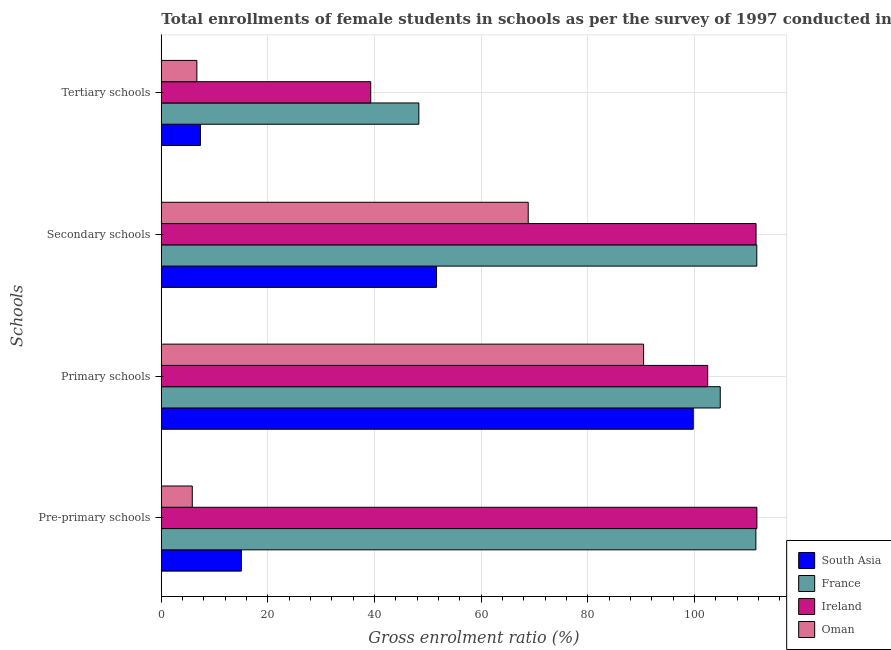How many groups of bars are there?
Make the answer very short. 4. Are the number of bars per tick equal to the number of legend labels?
Ensure brevity in your answer.  Yes. How many bars are there on the 4th tick from the top?
Offer a terse response. 4. What is the label of the 3rd group of bars from the top?
Offer a terse response. Primary schools. What is the gross enrolment ratio(female) in primary schools in Ireland?
Your answer should be compact. 102.49. Across all countries, what is the maximum gross enrolment ratio(female) in pre-primary schools?
Make the answer very short. 111.72. Across all countries, what is the minimum gross enrolment ratio(female) in secondary schools?
Provide a short and direct response. 51.63. In which country was the gross enrolment ratio(female) in pre-primary schools maximum?
Ensure brevity in your answer.  Ireland. In which country was the gross enrolment ratio(female) in primary schools minimum?
Your response must be concise. Oman. What is the total gross enrolment ratio(female) in secondary schools in the graph?
Your answer should be compact. 343.73. What is the difference between the gross enrolment ratio(female) in primary schools in South Asia and that in Oman?
Provide a succinct answer. 9.31. What is the difference between the gross enrolment ratio(female) in secondary schools in South Asia and the gross enrolment ratio(female) in tertiary schools in Ireland?
Your answer should be compact. 12.35. What is the average gross enrolment ratio(female) in tertiary schools per country?
Provide a succinct answer. 25.4. What is the difference between the gross enrolment ratio(female) in tertiary schools and gross enrolment ratio(female) in secondary schools in Oman?
Provide a short and direct response. -62.16. What is the ratio of the gross enrolment ratio(female) in primary schools in Oman to that in France?
Make the answer very short. 0.86. What is the difference between the highest and the second highest gross enrolment ratio(female) in pre-primary schools?
Your answer should be compact. 0.19. What is the difference between the highest and the lowest gross enrolment ratio(female) in pre-primary schools?
Your response must be concise. 105.91. In how many countries, is the gross enrolment ratio(female) in tertiary schools greater than the average gross enrolment ratio(female) in tertiary schools taken over all countries?
Your answer should be compact. 2. Is it the case that in every country, the sum of the gross enrolment ratio(female) in pre-primary schools and gross enrolment ratio(female) in primary schools is greater than the sum of gross enrolment ratio(female) in tertiary schools and gross enrolment ratio(female) in secondary schools?
Provide a short and direct response. Yes. What does the 1st bar from the top in Tertiary schools represents?
Offer a terse response. Oman. What does the 4th bar from the bottom in Tertiary schools represents?
Provide a succinct answer. Oman. How many bars are there?
Give a very brief answer. 16. How many countries are there in the graph?
Provide a succinct answer. 4. Does the graph contain grids?
Provide a succinct answer. Yes. How many legend labels are there?
Make the answer very short. 4. What is the title of the graph?
Offer a terse response. Total enrollments of female students in schools as per the survey of 1997 conducted in different countries. What is the label or title of the X-axis?
Your answer should be very brief. Gross enrolment ratio (%). What is the label or title of the Y-axis?
Provide a short and direct response. Schools. What is the Gross enrolment ratio (%) of South Asia in Pre-primary schools?
Your answer should be very brief. 15.01. What is the Gross enrolment ratio (%) in France in Pre-primary schools?
Your response must be concise. 111.53. What is the Gross enrolment ratio (%) of Ireland in Pre-primary schools?
Provide a short and direct response. 111.72. What is the Gross enrolment ratio (%) of Oman in Pre-primary schools?
Give a very brief answer. 5.81. What is the Gross enrolment ratio (%) in South Asia in Primary schools?
Keep it short and to the point. 99.79. What is the Gross enrolment ratio (%) of France in Primary schools?
Your response must be concise. 104.85. What is the Gross enrolment ratio (%) in Ireland in Primary schools?
Provide a short and direct response. 102.49. What is the Gross enrolment ratio (%) in Oman in Primary schools?
Provide a succinct answer. 90.47. What is the Gross enrolment ratio (%) in South Asia in Secondary schools?
Your answer should be compact. 51.63. What is the Gross enrolment ratio (%) of France in Secondary schools?
Keep it short and to the point. 111.7. What is the Gross enrolment ratio (%) in Ireland in Secondary schools?
Ensure brevity in your answer.  111.57. What is the Gross enrolment ratio (%) of Oman in Secondary schools?
Make the answer very short. 68.83. What is the Gross enrolment ratio (%) in South Asia in Tertiary schools?
Your answer should be compact. 7.34. What is the Gross enrolment ratio (%) of France in Tertiary schools?
Give a very brief answer. 48.31. What is the Gross enrolment ratio (%) in Ireland in Tertiary schools?
Make the answer very short. 39.28. What is the Gross enrolment ratio (%) in Oman in Tertiary schools?
Your answer should be compact. 6.67. Across all Schools, what is the maximum Gross enrolment ratio (%) in South Asia?
Your answer should be very brief. 99.79. Across all Schools, what is the maximum Gross enrolment ratio (%) in France?
Your answer should be very brief. 111.7. Across all Schools, what is the maximum Gross enrolment ratio (%) in Ireland?
Ensure brevity in your answer.  111.72. Across all Schools, what is the maximum Gross enrolment ratio (%) of Oman?
Your answer should be compact. 90.47. Across all Schools, what is the minimum Gross enrolment ratio (%) of South Asia?
Ensure brevity in your answer.  7.34. Across all Schools, what is the minimum Gross enrolment ratio (%) of France?
Provide a succinct answer. 48.31. Across all Schools, what is the minimum Gross enrolment ratio (%) in Ireland?
Offer a very short reply. 39.28. Across all Schools, what is the minimum Gross enrolment ratio (%) in Oman?
Provide a succinct answer. 5.81. What is the total Gross enrolment ratio (%) in South Asia in the graph?
Keep it short and to the point. 173.77. What is the total Gross enrolment ratio (%) of France in the graph?
Your response must be concise. 376.4. What is the total Gross enrolment ratio (%) in Ireland in the graph?
Your answer should be very brief. 365.07. What is the total Gross enrolment ratio (%) in Oman in the graph?
Make the answer very short. 171.78. What is the difference between the Gross enrolment ratio (%) in South Asia in Pre-primary schools and that in Primary schools?
Make the answer very short. -84.77. What is the difference between the Gross enrolment ratio (%) in France in Pre-primary schools and that in Primary schools?
Ensure brevity in your answer.  6.68. What is the difference between the Gross enrolment ratio (%) of Ireland in Pre-primary schools and that in Primary schools?
Keep it short and to the point. 9.23. What is the difference between the Gross enrolment ratio (%) of Oman in Pre-primary schools and that in Primary schools?
Make the answer very short. -84.66. What is the difference between the Gross enrolment ratio (%) in South Asia in Pre-primary schools and that in Secondary schools?
Keep it short and to the point. -36.62. What is the difference between the Gross enrolment ratio (%) of France in Pre-primary schools and that in Secondary schools?
Ensure brevity in your answer.  -0.17. What is the difference between the Gross enrolment ratio (%) in Ireland in Pre-primary schools and that in Secondary schools?
Your answer should be compact. 0.15. What is the difference between the Gross enrolment ratio (%) of Oman in Pre-primary schools and that in Secondary schools?
Ensure brevity in your answer.  -63.02. What is the difference between the Gross enrolment ratio (%) of South Asia in Pre-primary schools and that in Tertiary schools?
Give a very brief answer. 7.67. What is the difference between the Gross enrolment ratio (%) of France in Pre-primary schools and that in Tertiary schools?
Ensure brevity in your answer.  63.22. What is the difference between the Gross enrolment ratio (%) in Ireland in Pre-primary schools and that in Tertiary schools?
Your answer should be very brief. 72.44. What is the difference between the Gross enrolment ratio (%) of Oman in Pre-primary schools and that in Tertiary schools?
Provide a succinct answer. -0.86. What is the difference between the Gross enrolment ratio (%) in South Asia in Primary schools and that in Secondary schools?
Your answer should be very brief. 48.16. What is the difference between the Gross enrolment ratio (%) in France in Primary schools and that in Secondary schools?
Provide a succinct answer. -6.85. What is the difference between the Gross enrolment ratio (%) of Ireland in Primary schools and that in Secondary schools?
Your answer should be compact. -9.07. What is the difference between the Gross enrolment ratio (%) of Oman in Primary schools and that in Secondary schools?
Provide a succinct answer. 21.64. What is the difference between the Gross enrolment ratio (%) of South Asia in Primary schools and that in Tertiary schools?
Provide a short and direct response. 92.44. What is the difference between the Gross enrolment ratio (%) in France in Primary schools and that in Tertiary schools?
Provide a succinct answer. 56.54. What is the difference between the Gross enrolment ratio (%) in Ireland in Primary schools and that in Tertiary schools?
Offer a terse response. 63.21. What is the difference between the Gross enrolment ratio (%) of Oman in Primary schools and that in Tertiary schools?
Make the answer very short. 83.8. What is the difference between the Gross enrolment ratio (%) of South Asia in Secondary schools and that in Tertiary schools?
Your answer should be compact. 44.29. What is the difference between the Gross enrolment ratio (%) of France in Secondary schools and that in Tertiary schools?
Your answer should be very brief. 63.39. What is the difference between the Gross enrolment ratio (%) of Ireland in Secondary schools and that in Tertiary schools?
Your response must be concise. 72.28. What is the difference between the Gross enrolment ratio (%) of Oman in Secondary schools and that in Tertiary schools?
Provide a short and direct response. 62.16. What is the difference between the Gross enrolment ratio (%) in South Asia in Pre-primary schools and the Gross enrolment ratio (%) in France in Primary schools?
Keep it short and to the point. -89.84. What is the difference between the Gross enrolment ratio (%) of South Asia in Pre-primary schools and the Gross enrolment ratio (%) of Ireland in Primary schools?
Your answer should be compact. -87.48. What is the difference between the Gross enrolment ratio (%) in South Asia in Pre-primary schools and the Gross enrolment ratio (%) in Oman in Primary schools?
Give a very brief answer. -75.46. What is the difference between the Gross enrolment ratio (%) in France in Pre-primary schools and the Gross enrolment ratio (%) in Ireland in Primary schools?
Your answer should be compact. 9.04. What is the difference between the Gross enrolment ratio (%) of France in Pre-primary schools and the Gross enrolment ratio (%) of Oman in Primary schools?
Provide a short and direct response. 21.06. What is the difference between the Gross enrolment ratio (%) of Ireland in Pre-primary schools and the Gross enrolment ratio (%) of Oman in Primary schools?
Keep it short and to the point. 21.25. What is the difference between the Gross enrolment ratio (%) in South Asia in Pre-primary schools and the Gross enrolment ratio (%) in France in Secondary schools?
Your response must be concise. -96.69. What is the difference between the Gross enrolment ratio (%) in South Asia in Pre-primary schools and the Gross enrolment ratio (%) in Ireland in Secondary schools?
Provide a succinct answer. -96.56. What is the difference between the Gross enrolment ratio (%) in South Asia in Pre-primary schools and the Gross enrolment ratio (%) in Oman in Secondary schools?
Keep it short and to the point. -53.82. What is the difference between the Gross enrolment ratio (%) of France in Pre-primary schools and the Gross enrolment ratio (%) of Ireland in Secondary schools?
Provide a short and direct response. -0.04. What is the difference between the Gross enrolment ratio (%) of France in Pre-primary schools and the Gross enrolment ratio (%) of Oman in Secondary schools?
Your response must be concise. 42.7. What is the difference between the Gross enrolment ratio (%) of Ireland in Pre-primary schools and the Gross enrolment ratio (%) of Oman in Secondary schools?
Provide a short and direct response. 42.89. What is the difference between the Gross enrolment ratio (%) of South Asia in Pre-primary schools and the Gross enrolment ratio (%) of France in Tertiary schools?
Give a very brief answer. -33.3. What is the difference between the Gross enrolment ratio (%) in South Asia in Pre-primary schools and the Gross enrolment ratio (%) in Ireland in Tertiary schools?
Keep it short and to the point. -24.27. What is the difference between the Gross enrolment ratio (%) in South Asia in Pre-primary schools and the Gross enrolment ratio (%) in Oman in Tertiary schools?
Provide a succinct answer. 8.34. What is the difference between the Gross enrolment ratio (%) in France in Pre-primary schools and the Gross enrolment ratio (%) in Ireland in Tertiary schools?
Provide a succinct answer. 72.25. What is the difference between the Gross enrolment ratio (%) of France in Pre-primary schools and the Gross enrolment ratio (%) of Oman in Tertiary schools?
Your response must be concise. 104.86. What is the difference between the Gross enrolment ratio (%) in Ireland in Pre-primary schools and the Gross enrolment ratio (%) in Oman in Tertiary schools?
Give a very brief answer. 105.05. What is the difference between the Gross enrolment ratio (%) of South Asia in Primary schools and the Gross enrolment ratio (%) of France in Secondary schools?
Give a very brief answer. -11.92. What is the difference between the Gross enrolment ratio (%) in South Asia in Primary schools and the Gross enrolment ratio (%) in Ireland in Secondary schools?
Give a very brief answer. -11.78. What is the difference between the Gross enrolment ratio (%) in South Asia in Primary schools and the Gross enrolment ratio (%) in Oman in Secondary schools?
Keep it short and to the point. 30.96. What is the difference between the Gross enrolment ratio (%) in France in Primary schools and the Gross enrolment ratio (%) in Ireland in Secondary schools?
Provide a succinct answer. -6.72. What is the difference between the Gross enrolment ratio (%) of France in Primary schools and the Gross enrolment ratio (%) of Oman in Secondary schools?
Provide a succinct answer. 36.02. What is the difference between the Gross enrolment ratio (%) of Ireland in Primary schools and the Gross enrolment ratio (%) of Oman in Secondary schools?
Provide a short and direct response. 33.67. What is the difference between the Gross enrolment ratio (%) in South Asia in Primary schools and the Gross enrolment ratio (%) in France in Tertiary schools?
Give a very brief answer. 51.47. What is the difference between the Gross enrolment ratio (%) in South Asia in Primary schools and the Gross enrolment ratio (%) in Ireland in Tertiary schools?
Keep it short and to the point. 60.5. What is the difference between the Gross enrolment ratio (%) in South Asia in Primary schools and the Gross enrolment ratio (%) in Oman in Tertiary schools?
Offer a terse response. 93.11. What is the difference between the Gross enrolment ratio (%) in France in Primary schools and the Gross enrolment ratio (%) in Ireland in Tertiary schools?
Your answer should be very brief. 65.57. What is the difference between the Gross enrolment ratio (%) of France in Primary schools and the Gross enrolment ratio (%) of Oman in Tertiary schools?
Make the answer very short. 98.18. What is the difference between the Gross enrolment ratio (%) of Ireland in Primary schools and the Gross enrolment ratio (%) of Oman in Tertiary schools?
Your answer should be very brief. 95.82. What is the difference between the Gross enrolment ratio (%) in South Asia in Secondary schools and the Gross enrolment ratio (%) in France in Tertiary schools?
Make the answer very short. 3.32. What is the difference between the Gross enrolment ratio (%) of South Asia in Secondary schools and the Gross enrolment ratio (%) of Ireland in Tertiary schools?
Offer a terse response. 12.35. What is the difference between the Gross enrolment ratio (%) in South Asia in Secondary schools and the Gross enrolment ratio (%) in Oman in Tertiary schools?
Ensure brevity in your answer.  44.96. What is the difference between the Gross enrolment ratio (%) in France in Secondary schools and the Gross enrolment ratio (%) in Ireland in Tertiary schools?
Give a very brief answer. 72.42. What is the difference between the Gross enrolment ratio (%) of France in Secondary schools and the Gross enrolment ratio (%) of Oman in Tertiary schools?
Make the answer very short. 105.03. What is the difference between the Gross enrolment ratio (%) in Ireland in Secondary schools and the Gross enrolment ratio (%) in Oman in Tertiary schools?
Keep it short and to the point. 104.9. What is the average Gross enrolment ratio (%) of South Asia per Schools?
Provide a succinct answer. 43.44. What is the average Gross enrolment ratio (%) of France per Schools?
Keep it short and to the point. 94.1. What is the average Gross enrolment ratio (%) in Ireland per Schools?
Make the answer very short. 91.27. What is the average Gross enrolment ratio (%) in Oman per Schools?
Keep it short and to the point. 42.94. What is the difference between the Gross enrolment ratio (%) of South Asia and Gross enrolment ratio (%) of France in Pre-primary schools?
Ensure brevity in your answer.  -96.52. What is the difference between the Gross enrolment ratio (%) in South Asia and Gross enrolment ratio (%) in Ireland in Pre-primary schools?
Give a very brief answer. -96.71. What is the difference between the Gross enrolment ratio (%) of South Asia and Gross enrolment ratio (%) of Oman in Pre-primary schools?
Make the answer very short. 9.2. What is the difference between the Gross enrolment ratio (%) of France and Gross enrolment ratio (%) of Ireland in Pre-primary schools?
Provide a succinct answer. -0.19. What is the difference between the Gross enrolment ratio (%) in France and Gross enrolment ratio (%) in Oman in Pre-primary schools?
Your response must be concise. 105.72. What is the difference between the Gross enrolment ratio (%) of Ireland and Gross enrolment ratio (%) of Oman in Pre-primary schools?
Offer a terse response. 105.91. What is the difference between the Gross enrolment ratio (%) of South Asia and Gross enrolment ratio (%) of France in Primary schools?
Your answer should be compact. -5.06. What is the difference between the Gross enrolment ratio (%) of South Asia and Gross enrolment ratio (%) of Ireland in Primary schools?
Keep it short and to the point. -2.71. What is the difference between the Gross enrolment ratio (%) of South Asia and Gross enrolment ratio (%) of Oman in Primary schools?
Your response must be concise. 9.31. What is the difference between the Gross enrolment ratio (%) of France and Gross enrolment ratio (%) of Ireland in Primary schools?
Give a very brief answer. 2.36. What is the difference between the Gross enrolment ratio (%) of France and Gross enrolment ratio (%) of Oman in Primary schools?
Provide a short and direct response. 14.38. What is the difference between the Gross enrolment ratio (%) of Ireland and Gross enrolment ratio (%) of Oman in Primary schools?
Give a very brief answer. 12.02. What is the difference between the Gross enrolment ratio (%) of South Asia and Gross enrolment ratio (%) of France in Secondary schools?
Keep it short and to the point. -60.08. What is the difference between the Gross enrolment ratio (%) of South Asia and Gross enrolment ratio (%) of Ireland in Secondary schools?
Give a very brief answer. -59.94. What is the difference between the Gross enrolment ratio (%) in South Asia and Gross enrolment ratio (%) in Oman in Secondary schools?
Offer a terse response. -17.2. What is the difference between the Gross enrolment ratio (%) in France and Gross enrolment ratio (%) in Ireland in Secondary schools?
Your response must be concise. 0.14. What is the difference between the Gross enrolment ratio (%) in France and Gross enrolment ratio (%) in Oman in Secondary schools?
Give a very brief answer. 42.88. What is the difference between the Gross enrolment ratio (%) in Ireland and Gross enrolment ratio (%) in Oman in Secondary schools?
Provide a short and direct response. 42.74. What is the difference between the Gross enrolment ratio (%) of South Asia and Gross enrolment ratio (%) of France in Tertiary schools?
Your answer should be compact. -40.97. What is the difference between the Gross enrolment ratio (%) of South Asia and Gross enrolment ratio (%) of Ireland in Tertiary schools?
Give a very brief answer. -31.94. What is the difference between the Gross enrolment ratio (%) in South Asia and Gross enrolment ratio (%) in Oman in Tertiary schools?
Your response must be concise. 0.67. What is the difference between the Gross enrolment ratio (%) in France and Gross enrolment ratio (%) in Ireland in Tertiary schools?
Your answer should be very brief. 9.03. What is the difference between the Gross enrolment ratio (%) in France and Gross enrolment ratio (%) in Oman in Tertiary schools?
Offer a very short reply. 41.64. What is the difference between the Gross enrolment ratio (%) in Ireland and Gross enrolment ratio (%) in Oman in Tertiary schools?
Your response must be concise. 32.61. What is the ratio of the Gross enrolment ratio (%) of South Asia in Pre-primary schools to that in Primary schools?
Your answer should be compact. 0.15. What is the ratio of the Gross enrolment ratio (%) in France in Pre-primary schools to that in Primary schools?
Your answer should be very brief. 1.06. What is the ratio of the Gross enrolment ratio (%) in Ireland in Pre-primary schools to that in Primary schools?
Your answer should be very brief. 1.09. What is the ratio of the Gross enrolment ratio (%) of Oman in Pre-primary schools to that in Primary schools?
Provide a short and direct response. 0.06. What is the ratio of the Gross enrolment ratio (%) of South Asia in Pre-primary schools to that in Secondary schools?
Your response must be concise. 0.29. What is the ratio of the Gross enrolment ratio (%) in France in Pre-primary schools to that in Secondary schools?
Offer a terse response. 1. What is the ratio of the Gross enrolment ratio (%) of Ireland in Pre-primary schools to that in Secondary schools?
Your response must be concise. 1. What is the ratio of the Gross enrolment ratio (%) in Oman in Pre-primary schools to that in Secondary schools?
Give a very brief answer. 0.08. What is the ratio of the Gross enrolment ratio (%) in South Asia in Pre-primary schools to that in Tertiary schools?
Offer a very short reply. 2.04. What is the ratio of the Gross enrolment ratio (%) in France in Pre-primary schools to that in Tertiary schools?
Your answer should be compact. 2.31. What is the ratio of the Gross enrolment ratio (%) of Ireland in Pre-primary schools to that in Tertiary schools?
Provide a succinct answer. 2.84. What is the ratio of the Gross enrolment ratio (%) of Oman in Pre-primary schools to that in Tertiary schools?
Provide a short and direct response. 0.87. What is the ratio of the Gross enrolment ratio (%) of South Asia in Primary schools to that in Secondary schools?
Give a very brief answer. 1.93. What is the ratio of the Gross enrolment ratio (%) of France in Primary schools to that in Secondary schools?
Make the answer very short. 0.94. What is the ratio of the Gross enrolment ratio (%) of Ireland in Primary schools to that in Secondary schools?
Provide a short and direct response. 0.92. What is the ratio of the Gross enrolment ratio (%) of Oman in Primary schools to that in Secondary schools?
Offer a terse response. 1.31. What is the ratio of the Gross enrolment ratio (%) in South Asia in Primary schools to that in Tertiary schools?
Your answer should be compact. 13.59. What is the ratio of the Gross enrolment ratio (%) of France in Primary schools to that in Tertiary schools?
Provide a short and direct response. 2.17. What is the ratio of the Gross enrolment ratio (%) in Ireland in Primary schools to that in Tertiary schools?
Give a very brief answer. 2.61. What is the ratio of the Gross enrolment ratio (%) of Oman in Primary schools to that in Tertiary schools?
Make the answer very short. 13.56. What is the ratio of the Gross enrolment ratio (%) in South Asia in Secondary schools to that in Tertiary schools?
Offer a very short reply. 7.03. What is the ratio of the Gross enrolment ratio (%) of France in Secondary schools to that in Tertiary schools?
Ensure brevity in your answer.  2.31. What is the ratio of the Gross enrolment ratio (%) in Ireland in Secondary schools to that in Tertiary schools?
Offer a terse response. 2.84. What is the ratio of the Gross enrolment ratio (%) of Oman in Secondary schools to that in Tertiary schools?
Offer a terse response. 10.32. What is the difference between the highest and the second highest Gross enrolment ratio (%) of South Asia?
Provide a succinct answer. 48.16. What is the difference between the highest and the second highest Gross enrolment ratio (%) of France?
Offer a terse response. 0.17. What is the difference between the highest and the second highest Gross enrolment ratio (%) of Ireland?
Your answer should be very brief. 0.15. What is the difference between the highest and the second highest Gross enrolment ratio (%) in Oman?
Provide a succinct answer. 21.64. What is the difference between the highest and the lowest Gross enrolment ratio (%) in South Asia?
Offer a terse response. 92.44. What is the difference between the highest and the lowest Gross enrolment ratio (%) of France?
Your answer should be compact. 63.39. What is the difference between the highest and the lowest Gross enrolment ratio (%) of Ireland?
Your answer should be very brief. 72.44. What is the difference between the highest and the lowest Gross enrolment ratio (%) of Oman?
Provide a short and direct response. 84.66. 